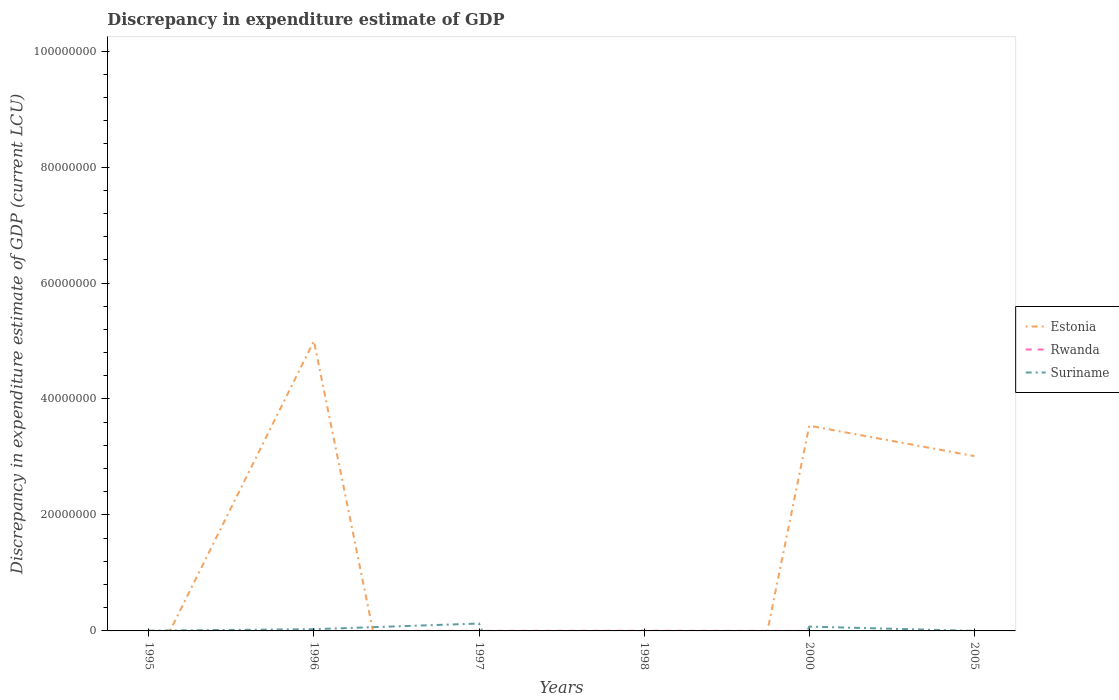How many different coloured lines are there?
Make the answer very short. 3. What is the total discrepancy in expenditure estimate of GDP in Suriname in the graph?
Your response must be concise. -2.52e+05. What is the difference between the highest and the second highest discrepancy in expenditure estimate of GDP in Estonia?
Give a very brief answer. 5.00e+07. Is the discrepancy in expenditure estimate of GDP in Suriname strictly greater than the discrepancy in expenditure estimate of GDP in Rwanda over the years?
Ensure brevity in your answer.  No. How many years are there in the graph?
Your response must be concise. 6. Does the graph contain grids?
Ensure brevity in your answer.  No. What is the title of the graph?
Provide a succinct answer. Discrepancy in expenditure estimate of GDP. What is the label or title of the Y-axis?
Keep it short and to the point. Discrepancy in expenditure estimate of GDP (current LCU). What is the Discrepancy in expenditure estimate of GDP (current LCU) in Estonia in 1995?
Make the answer very short. 0. What is the Discrepancy in expenditure estimate of GDP (current LCU) in Suriname in 1995?
Keep it short and to the point. 4.70e+04. What is the Discrepancy in expenditure estimate of GDP (current LCU) of Suriname in 1996?
Ensure brevity in your answer.  2.98e+05. What is the Discrepancy in expenditure estimate of GDP (current LCU) in Rwanda in 1997?
Ensure brevity in your answer.  1.65e+04. What is the Discrepancy in expenditure estimate of GDP (current LCU) of Suriname in 1997?
Offer a very short reply. 1.27e+06. What is the Discrepancy in expenditure estimate of GDP (current LCU) in Estonia in 1998?
Your answer should be compact. 0. What is the Discrepancy in expenditure estimate of GDP (current LCU) in Rwanda in 1998?
Your answer should be very brief. 2.87e+04. What is the Discrepancy in expenditure estimate of GDP (current LCU) of Suriname in 1998?
Give a very brief answer. 0. What is the Discrepancy in expenditure estimate of GDP (current LCU) in Estonia in 2000?
Provide a short and direct response. 3.54e+07. What is the Discrepancy in expenditure estimate of GDP (current LCU) in Suriname in 2000?
Your answer should be compact. 7.48e+05. What is the Discrepancy in expenditure estimate of GDP (current LCU) of Estonia in 2005?
Provide a short and direct response. 3.02e+07. Across all years, what is the maximum Discrepancy in expenditure estimate of GDP (current LCU) of Estonia?
Make the answer very short. 5.00e+07. Across all years, what is the maximum Discrepancy in expenditure estimate of GDP (current LCU) in Rwanda?
Make the answer very short. 2.87e+04. Across all years, what is the maximum Discrepancy in expenditure estimate of GDP (current LCU) of Suriname?
Offer a terse response. 1.27e+06. Across all years, what is the minimum Discrepancy in expenditure estimate of GDP (current LCU) in Estonia?
Your answer should be very brief. 0. Across all years, what is the minimum Discrepancy in expenditure estimate of GDP (current LCU) in Rwanda?
Offer a very short reply. 0. Across all years, what is the minimum Discrepancy in expenditure estimate of GDP (current LCU) of Suriname?
Offer a terse response. 0. What is the total Discrepancy in expenditure estimate of GDP (current LCU) of Estonia in the graph?
Make the answer very short. 1.16e+08. What is the total Discrepancy in expenditure estimate of GDP (current LCU) of Rwanda in the graph?
Offer a very short reply. 4.52e+04. What is the total Discrepancy in expenditure estimate of GDP (current LCU) in Suriname in the graph?
Your answer should be compact. 2.37e+06. What is the difference between the Discrepancy in expenditure estimate of GDP (current LCU) in Suriname in 1995 and that in 1996?
Provide a succinct answer. -2.52e+05. What is the difference between the Discrepancy in expenditure estimate of GDP (current LCU) of Suriname in 1995 and that in 1997?
Your answer should be compact. -1.23e+06. What is the difference between the Discrepancy in expenditure estimate of GDP (current LCU) in Suriname in 1995 and that in 2000?
Offer a terse response. -7.01e+05. What is the difference between the Discrepancy in expenditure estimate of GDP (current LCU) of Suriname in 1995 and that in 2005?
Your answer should be compact. 4.69e+04. What is the difference between the Discrepancy in expenditure estimate of GDP (current LCU) of Suriname in 1996 and that in 1997?
Provide a short and direct response. -9.74e+05. What is the difference between the Discrepancy in expenditure estimate of GDP (current LCU) in Estonia in 1996 and that in 2000?
Your answer should be compact. 1.46e+07. What is the difference between the Discrepancy in expenditure estimate of GDP (current LCU) in Suriname in 1996 and that in 2000?
Keep it short and to the point. -4.50e+05. What is the difference between the Discrepancy in expenditure estimate of GDP (current LCU) in Estonia in 1996 and that in 2005?
Your answer should be very brief. 1.98e+07. What is the difference between the Discrepancy in expenditure estimate of GDP (current LCU) of Suriname in 1996 and that in 2005?
Provide a short and direct response. 2.98e+05. What is the difference between the Discrepancy in expenditure estimate of GDP (current LCU) of Rwanda in 1997 and that in 1998?
Your answer should be very brief. -1.22e+04. What is the difference between the Discrepancy in expenditure estimate of GDP (current LCU) of Suriname in 1997 and that in 2000?
Keep it short and to the point. 5.25e+05. What is the difference between the Discrepancy in expenditure estimate of GDP (current LCU) in Suriname in 1997 and that in 2005?
Your answer should be compact. 1.27e+06. What is the difference between the Discrepancy in expenditure estimate of GDP (current LCU) in Estonia in 2000 and that in 2005?
Provide a succinct answer. 5.24e+06. What is the difference between the Discrepancy in expenditure estimate of GDP (current LCU) in Suriname in 2000 and that in 2005?
Offer a terse response. 7.48e+05. What is the difference between the Discrepancy in expenditure estimate of GDP (current LCU) in Estonia in 1996 and the Discrepancy in expenditure estimate of GDP (current LCU) in Rwanda in 1997?
Keep it short and to the point. 5.00e+07. What is the difference between the Discrepancy in expenditure estimate of GDP (current LCU) in Estonia in 1996 and the Discrepancy in expenditure estimate of GDP (current LCU) in Suriname in 1997?
Make the answer very short. 4.87e+07. What is the difference between the Discrepancy in expenditure estimate of GDP (current LCU) of Estonia in 1996 and the Discrepancy in expenditure estimate of GDP (current LCU) of Rwanda in 1998?
Your response must be concise. 5.00e+07. What is the difference between the Discrepancy in expenditure estimate of GDP (current LCU) of Estonia in 1996 and the Discrepancy in expenditure estimate of GDP (current LCU) of Suriname in 2000?
Ensure brevity in your answer.  4.93e+07. What is the difference between the Discrepancy in expenditure estimate of GDP (current LCU) of Estonia in 1996 and the Discrepancy in expenditure estimate of GDP (current LCU) of Suriname in 2005?
Give a very brief answer. 5.00e+07. What is the difference between the Discrepancy in expenditure estimate of GDP (current LCU) in Rwanda in 1997 and the Discrepancy in expenditure estimate of GDP (current LCU) in Suriname in 2000?
Provide a short and direct response. -7.32e+05. What is the difference between the Discrepancy in expenditure estimate of GDP (current LCU) of Rwanda in 1997 and the Discrepancy in expenditure estimate of GDP (current LCU) of Suriname in 2005?
Provide a short and direct response. 1.64e+04. What is the difference between the Discrepancy in expenditure estimate of GDP (current LCU) in Rwanda in 1998 and the Discrepancy in expenditure estimate of GDP (current LCU) in Suriname in 2000?
Make the answer very short. -7.19e+05. What is the difference between the Discrepancy in expenditure estimate of GDP (current LCU) of Rwanda in 1998 and the Discrepancy in expenditure estimate of GDP (current LCU) of Suriname in 2005?
Your response must be concise. 2.86e+04. What is the difference between the Discrepancy in expenditure estimate of GDP (current LCU) of Estonia in 2000 and the Discrepancy in expenditure estimate of GDP (current LCU) of Suriname in 2005?
Your answer should be very brief. 3.54e+07. What is the average Discrepancy in expenditure estimate of GDP (current LCU) of Estonia per year?
Provide a succinct answer. 1.93e+07. What is the average Discrepancy in expenditure estimate of GDP (current LCU) of Rwanda per year?
Ensure brevity in your answer.  7533.33. What is the average Discrepancy in expenditure estimate of GDP (current LCU) of Suriname per year?
Keep it short and to the point. 3.94e+05. In the year 1996, what is the difference between the Discrepancy in expenditure estimate of GDP (current LCU) in Estonia and Discrepancy in expenditure estimate of GDP (current LCU) in Suriname?
Give a very brief answer. 4.97e+07. In the year 1997, what is the difference between the Discrepancy in expenditure estimate of GDP (current LCU) of Rwanda and Discrepancy in expenditure estimate of GDP (current LCU) of Suriname?
Your response must be concise. -1.26e+06. In the year 2000, what is the difference between the Discrepancy in expenditure estimate of GDP (current LCU) in Estonia and Discrepancy in expenditure estimate of GDP (current LCU) in Suriname?
Offer a very short reply. 3.46e+07. In the year 2005, what is the difference between the Discrepancy in expenditure estimate of GDP (current LCU) in Estonia and Discrepancy in expenditure estimate of GDP (current LCU) in Suriname?
Provide a succinct answer. 3.01e+07. What is the ratio of the Discrepancy in expenditure estimate of GDP (current LCU) in Suriname in 1995 to that in 1996?
Your answer should be compact. 0.16. What is the ratio of the Discrepancy in expenditure estimate of GDP (current LCU) in Suriname in 1995 to that in 1997?
Offer a very short reply. 0.04. What is the ratio of the Discrepancy in expenditure estimate of GDP (current LCU) in Suriname in 1995 to that in 2000?
Offer a terse response. 0.06. What is the ratio of the Discrepancy in expenditure estimate of GDP (current LCU) of Suriname in 1995 to that in 2005?
Your response must be concise. 470. What is the ratio of the Discrepancy in expenditure estimate of GDP (current LCU) of Suriname in 1996 to that in 1997?
Your response must be concise. 0.23. What is the ratio of the Discrepancy in expenditure estimate of GDP (current LCU) of Estonia in 1996 to that in 2000?
Your response must be concise. 1.41. What is the ratio of the Discrepancy in expenditure estimate of GDP (current LCU) in Suriname in 1996 to that in 2000?
Offer a terse response. 0.4. What is the ratio of the Discrepancy in expenditure estimate of GDP (current LCU) of Estonia in 1996 to that in 2005?
Your answer should be compact. 1.66. What is the ratio of the Discrepancy in expenditure estimate of GDP (current LCU) in Suriname in 1996 to that in 2005?
Offer a terse response. 2985. What is the ratio of the Discrepancy in expenditure estimate of GDP (current LCU) of Rwanda in 1997 to that in 1998?
Your answer should be very brief. 0.57. What is the ratio of the Discrepancy in expenditure estimate of GDP (current LCU) in Suriname in 1997 to that in 2000?
Make the answer very short. 1.7. What is the ratio of the Discrepancy in expenditure estimate of GDP (current LCU) of Suriname in 1997 to that in 2005?
Provide a short and direct response. 1.27e+04. What is the ratio of the Discrepancy in expenditure estimate of GDP (current LCU) of Estonia in 2000 to that in 2005?
Provide a succinct answer. 1.17. What is the ratio of the Discrepancy in expenditure estimate of GDP (current LCU) of Suriname in 2000 to that in 2005?
Offer a terse response. 7481. What is the difference between the highest and the second highest Discrepancy in expenditure estimate of GDP (current LCU) of Estonia?
Ensure brevity in your answer.  1.46e+07. What is the difference between the highest and the second highest Discrepancy in expenditure estimate of GDP (current LCU) in Suriname?
Your answer should be very brief. 5.25e+05. What is the difference between the highest and the lowest Discrepancy in expenditure estimate of GDP (current LCU) in Rwanda?
Keep it short and to the point. 2.87e+04. What is the difference between the highest and the lowest Discrepancy in expenditure estimate of GDP (current LCU) in Suriname?
Keep it short and to the point. 1.27e+06. 